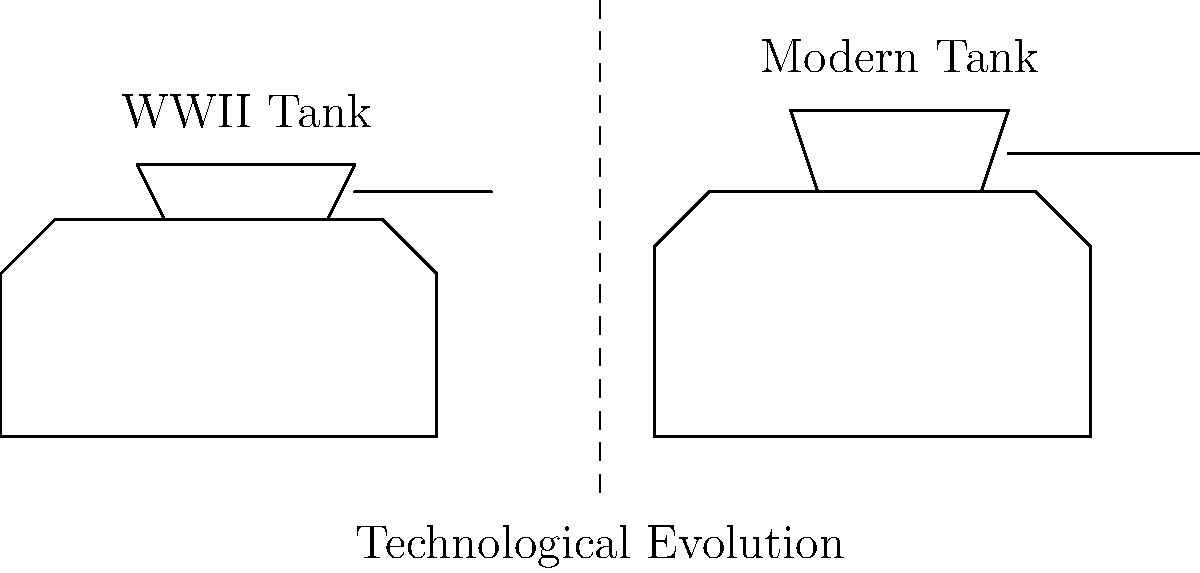Analyze the diagram comparing a WWII-era tank with a modern tank. What are the three most significant technological advancements evident in the modern tank design, and how do these improvements impact combat effectiveness? To answer this question, we need to carefully examine the diagram and consider the technological advancements in tank design from WWII to modern times:

1. Hull Design:
   - WWII tank: Relatively boxy shape with vertical sides
   - Modern tank: More angled and sloped armor
   Impact: Improved protection against enemy fire due to increased likelihood of deflection

2. Turret Design:
   - WWII tank: Smaller turret with less elevation
   - Modern tank: Larger turret with increased height and better gun depression/elevation
   Impact: Enhanced firing arc and ability to engage targets at various elevations

3. Main Gun:
   - WWII tank: Shorter, smaller caliber gun
   - Modern tank: Longer barrel, likely larger caliber
   Impact: Increased muzzle velocity, range, and penetration capabilities

Additional considerations (not explicitly shown but implied):
- Improved fire control systems and targeting computers
- Enhanced mobility and power-to-weight ratio
- Better crew protection and survivability features

These advancements collectively result in:
- Increased combat effectiveness
- Better survivability
- Enhanced lethality
- Improved tactical flexibility
Answer: 1. Sloped armor for better protection
2. Larger turret for improved firing arc
3. Longer gun barrel for increased range and penetration 